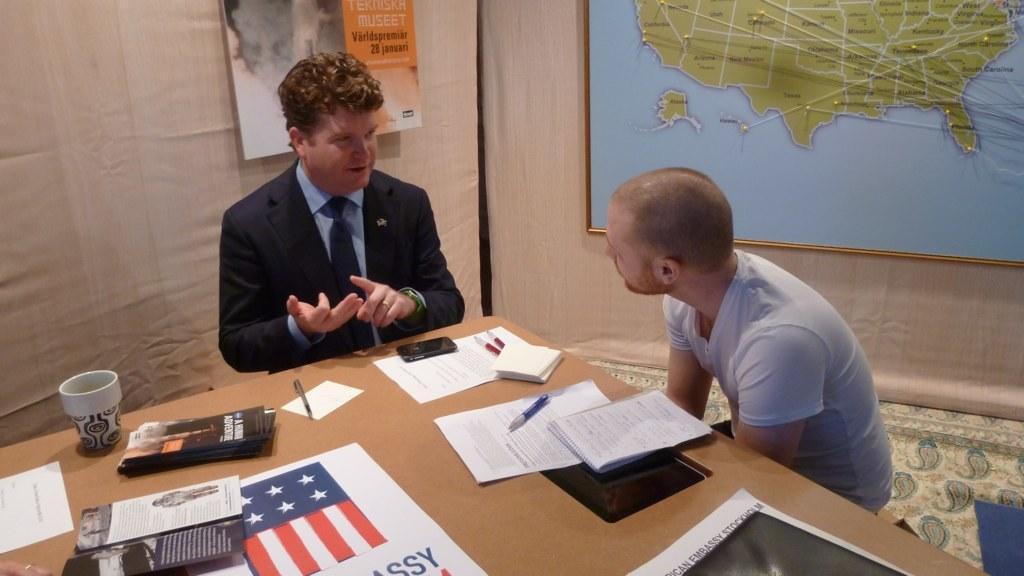Please provide a concise description of this image. In this picture we can see two men where there men wore blazer, tie and telling something to him and in front of them there is table and on table we can see cup, fence, paper, mobile, book and in background we can see wall with poster. 